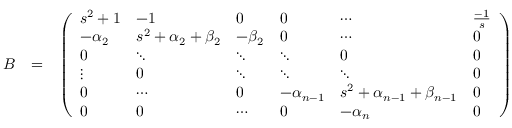<formula> <loc_0><loc_0><loc_500><loc_500>\begin{array} { r l r } { B } & { = } & { \left ( \begin{array} { l l l l l l } { s ^ { 2 } + 1 } & { - 1 } & { 0 } & { 0 } & { \cdots } & { \frac { - 1 } { s } } \\ { - \alpha _ { 2 } } & { s ^ { 2 } + \alpha _ { 2 } + \beta _ { 2 } } & { - \beta _ { 2 } } & { 0 } & { \cdots } & { 0 } \\ { 0 } & { \ddots } & { \ddots } & { \ddots } & { 0 } & { 0 } \\ { \vdots } & { 0 } & { \ddots } & { \ddots } & { \ddots } & { 0 } \\ { 0 } & { \cdots } & { 0 } & { - \alpha _ { n - 1 } } & { s ^ { 2 } + \alpha _ { n - 1 } + \beta _ { n - 1 } } & { 0 } \\ { 0 } & { 0 } & { \cdots } & { 0 } & { - \alpha _ { n } } & { 0 } \end{array} \right ) } \end{array}</formula> 